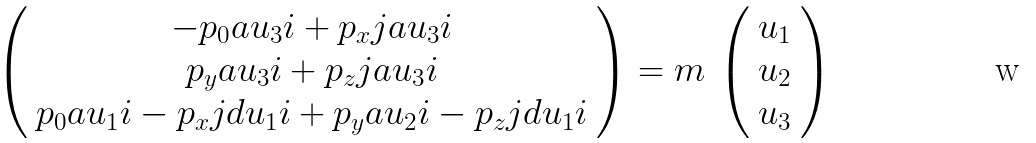Convert formula to latex. <formula><loc_0><loc_0><loc_500><loc_500>\left ( \begin{array} { c } { { - p _ { 0 } a u _ { 3 } i + p _ { x } j a u _ { 3 } i } } \\ { { p _ { y } a u _ { 3 } i + p _ { z } j a u _ { 3 } i } } \\ { { p _ { 0 } a u _ { 1 } i - p _ { x } j d u _ { 1 } i + p _ { y } a u _ { 2 } i - p _ { z } j d u _ { 1 } i } } \end{array} \right ) = m \, \left ( \begin{array} { c } { { u _ { 1 } } } \\ { { u _ { 2 } } } \\ { { u _ { 3 } } } \end{array} \right )</formula> 